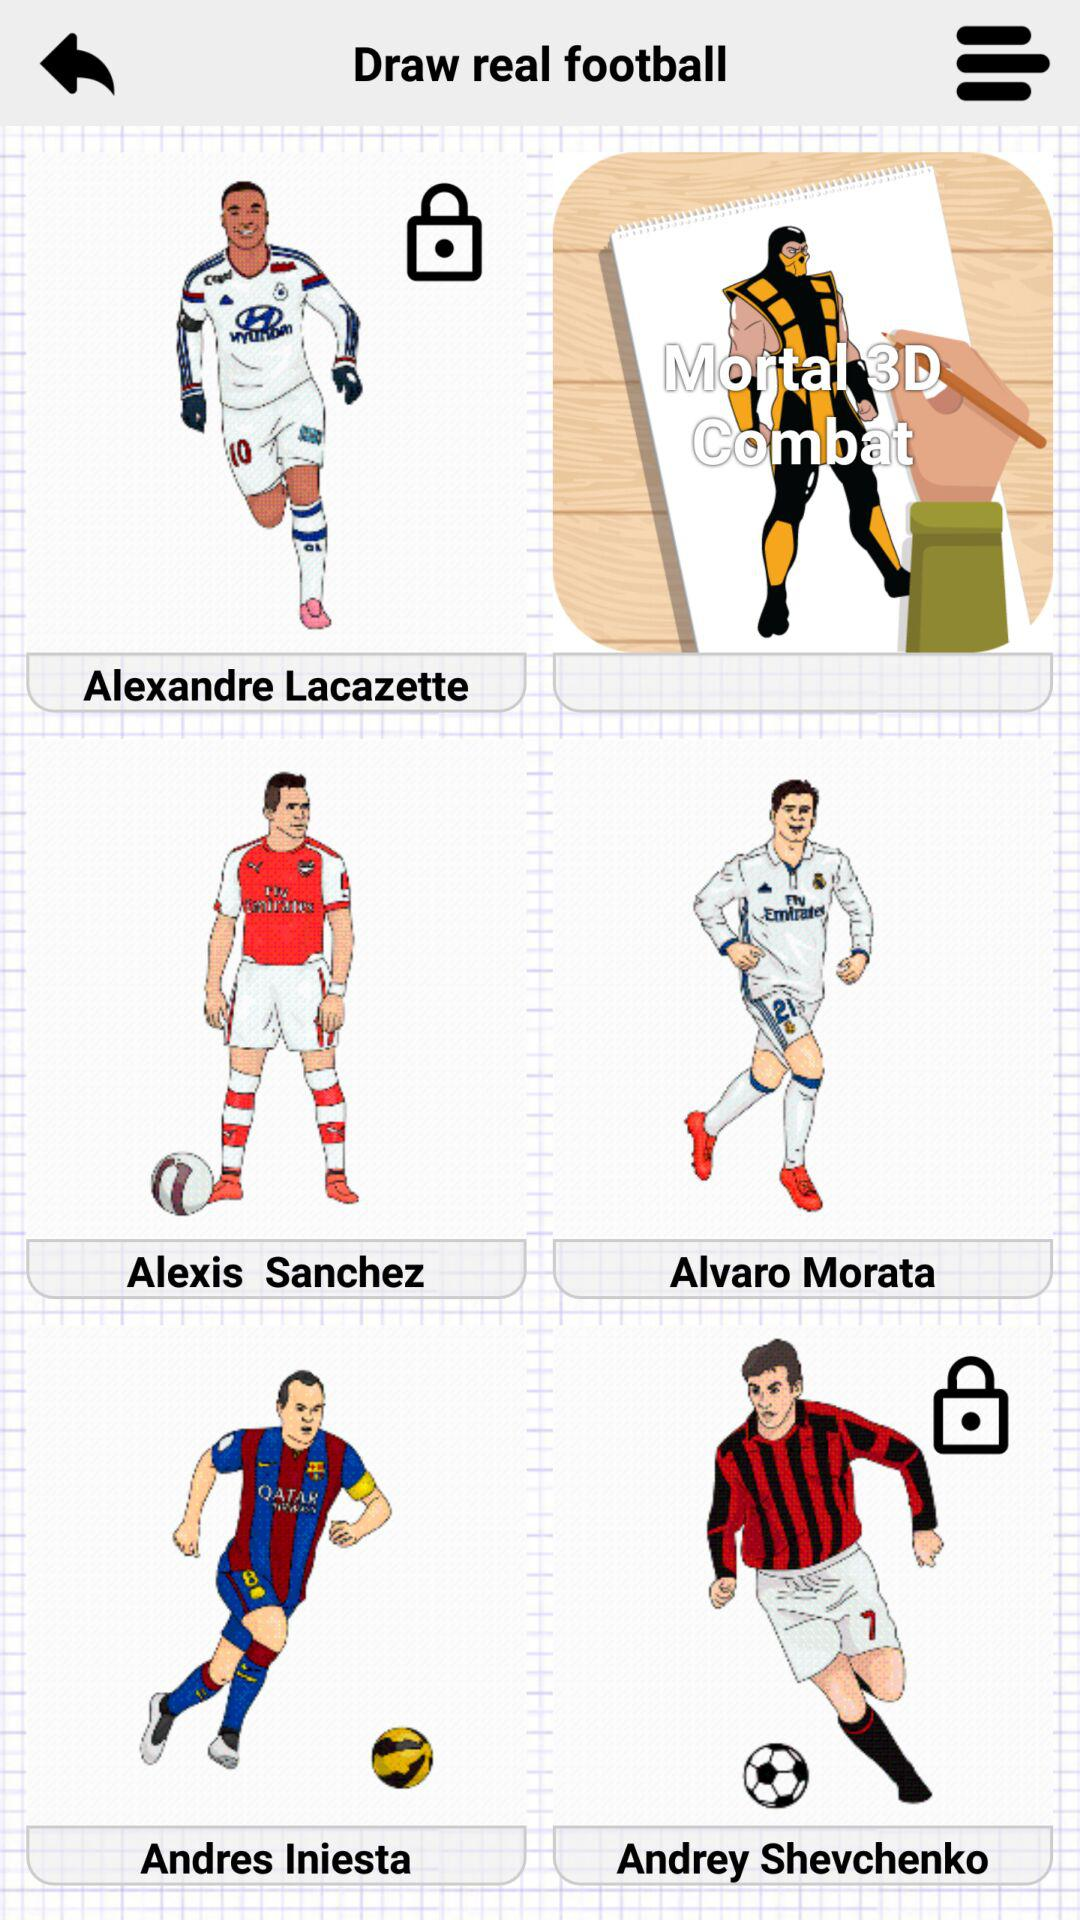What is the application name? The application name is "Draw real football". 